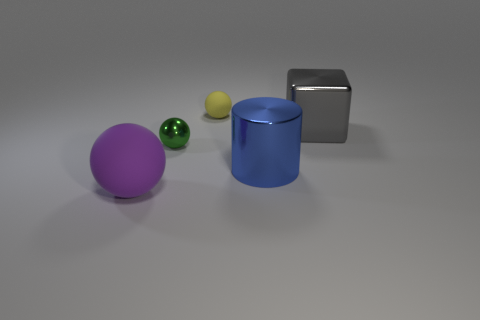The blue object has what size?
Give a very brief answer. Large. There is a matte ball on the right side of the big ball; what is its size?
Give a very brief answer. Small. There is a object that is both behind the tiny metal object and left of the large metallic block; what shape is it?
Offer a terse response. Sphere. What number of other objects are there of the same shape as the large purple thing?
Give a very brief answer. 2. What color is the matte thing that is the same size as the shiny cylinder?
Offer a terse response. Purple. What number of things are either small green balls or gray metallic balls?
Ensure brevity in your answer.  1. Are there any spheres in front of the small yellow rubber sphere?
Provide a succinct answer. Yes. Are there any other small spheres made of the same material as the yellow sphere?
Make the answer very short. No. How many spheres are either brown matte things or tiny objects?
Your answer should be compact. 2. Is the number of large shiny objects that are behind the blue shiny cylinder greater than the number of blue shiny cylinders that are in front of the big purple rubber thing?
Keep it short and to the point. Yes. 